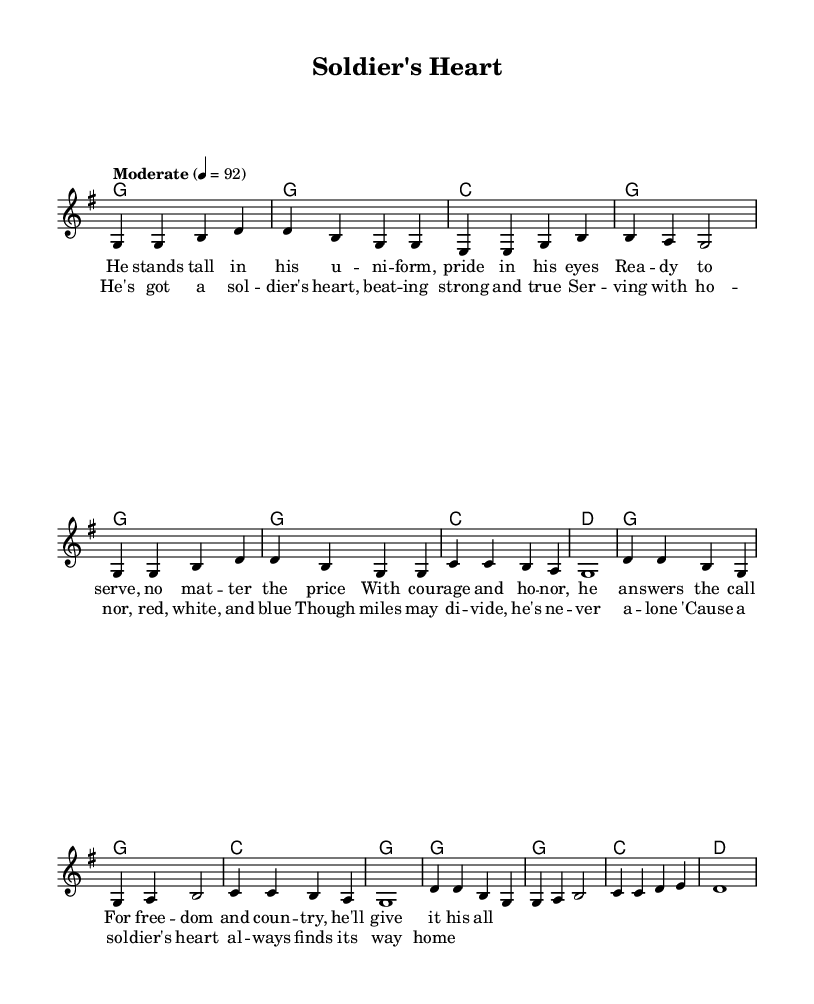What is the key signature of this music? The key signature is G major, which has one sharp (F#). This can be determined from the key indicated at the beginning of the score, which is noted as "g \major."
Answer: G major What is the time signature of this piece? The time signature is 4/4, indicated at the beginning of the music. This means there are four beats in a measure, and the quarter note receives one beat. This can be seen right after the key signature.
Answer: 4/4 What is the tempo marking for this piece? The tempo marking is "Moderate" with a metronome marking of quarter note = 92, which specifies how fast the piece should be played. This is explicitly mentioned in the music.
Answer: Moderate, 92 How many verses are in the song? There is one verse in this song, as indicated by the structure of the provided melody and lyrics, which consists of a single verse followed by a chorus, with no indication of additional verses.
Answer: One What musical form is used in this song? The musical form is Verse-Chorus structure, which is typical in Country music. This can be determined from the layout of the lyrics, where the verse is followed by the chorus.
Answer: Verse-Chorus What themes are present in the lyrics of this song? The themes present in the lyrics are patriotism, honor, and military service. This is evident in the content of the lyrics, which speak about serving the country and the valor of soldiers.
Answer: Patriotism, honor, military service What instrument is primarily featured in this piece? The piece is primarily composed for piano or similar instruments, as indicated by the presence of a staff and chord notation, which implies harmonization typical of country songs.
Answer: Piano 